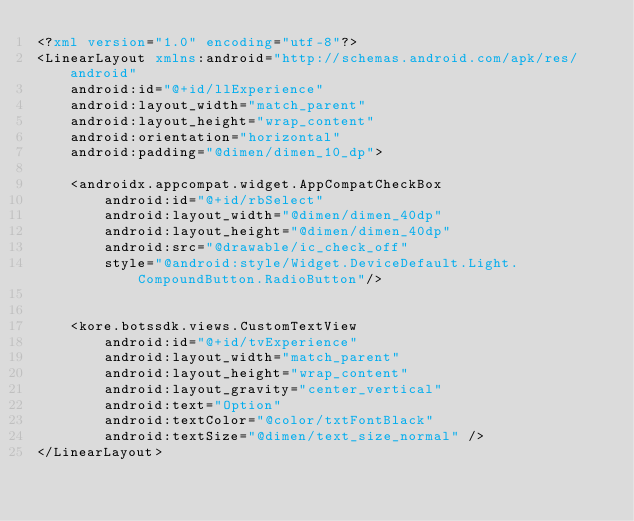<code> <loc_0><loc_0><loc_500><loc_500><_XML_><?xml version="1.0" encoding="utf-8"?>
<LinearLayout xmlns:android="http://schemas.android.com/apk/res/android"
    android:id="@+id/llExperience"
    android:layout_width="match_parent"
    android:layout_height="wrap_content"
    android:orientation="horizontal"
    android:padding="@dimen/dimen_10_dp">

    <androidx.appcompat.widget.AppCompatCheckBox
        android:id="@+id/rbSelect"
        android:layout_width="@dimen/dimen_40dp"
        android:layout_height="@dimen/dimen_40dp"
        android:src="@drawable/ic_check_off"
        style="@android:style/Widget.DeviceDefault.Light.CompoundButton.RadioButton"/>


    <kore.botssdk.views.CustomTextView
        android:id="@+id/tvExperience"
        android:layout_width="match_parent"
        android:layout_height="wrap_content"
        android:layout_gravity="center_vertical"
        android:text="Option"
        android:textColor="@color/txtFontBlack"
        android:textSize="@dimen/text_size_normal" />
</LinearLayout></code> 